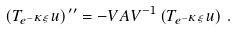Convert formula to latex. <formula><loc_0><loc_0><loc_500><loc_500>\left ( T _ { e ^ { - K \xi } } u \right ) ^ { \, \prime \prime } = - V A V ^ { - 1 } \left ( T _ { e ^ { - K \xi } } u \right ) \, .</formula> 